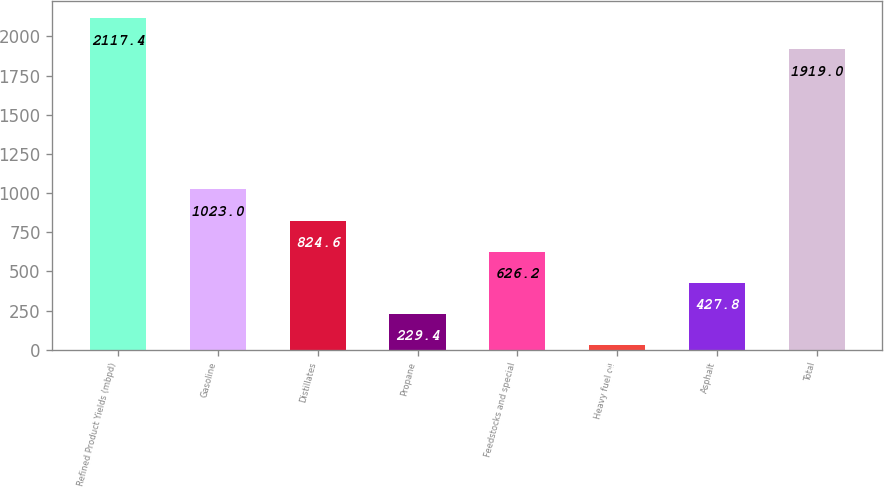Convert chart. <chart><loc_0><loc_0><loc_500><loc_500><bar_chart><fcel>Refined Product Yields (mbpd)<fcel>Gasoline<fcel>Distillates<fcel>Propane<fcel>Feedstocks and special<fcel>Heavy fuel oil<fcel>Asphalt<fcel>Total<nl><fcel>2117.4<fcel>1023<fcel>824.6<fcel>229.4<fcel>626.2<fcel>31<fcel>427.8<fcel>1919<nl></chart> 